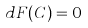Convert formula to latex. <formula><loc_0><loc_0><loc_500><loc_500>d F ( C ) = 0</formula> 